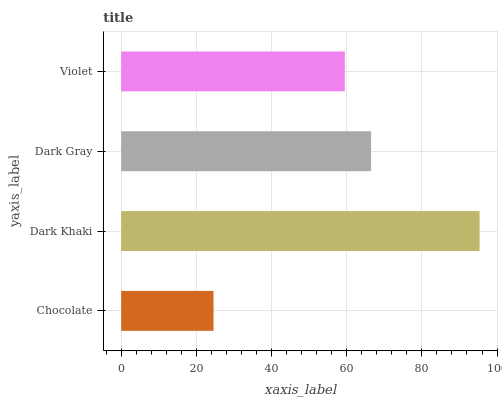Is Chocolate the minimum?
Answer yes or no. Yes. Is Dark Khaki the maximum?
Answer yes or no. Yes. Is Dark Gray the minimum?
Answer yes or no. No. Is Dark Gray the maximum?
Answer yes or no. No. Is Dark Khaki greater than Dark Gray?
Answer yes or no. Yes. Is Dark Gray less than Dark Khaki?
Answer yes or no. Yes. Is Dark Gray greater than Dark Khaki?
Answer yes or no. No. Is Dark Khaki less than Dark Gray?
Answer yes or no. No. Is Dark Gray the high median?
Answer yes or no. Yes. Is Violet the low median?
Answer yes or no. Yes. Is Dark Khaki the high median?
Answer yes or no. No. Is Chocolate the low median?
Answer yes or no. No. 